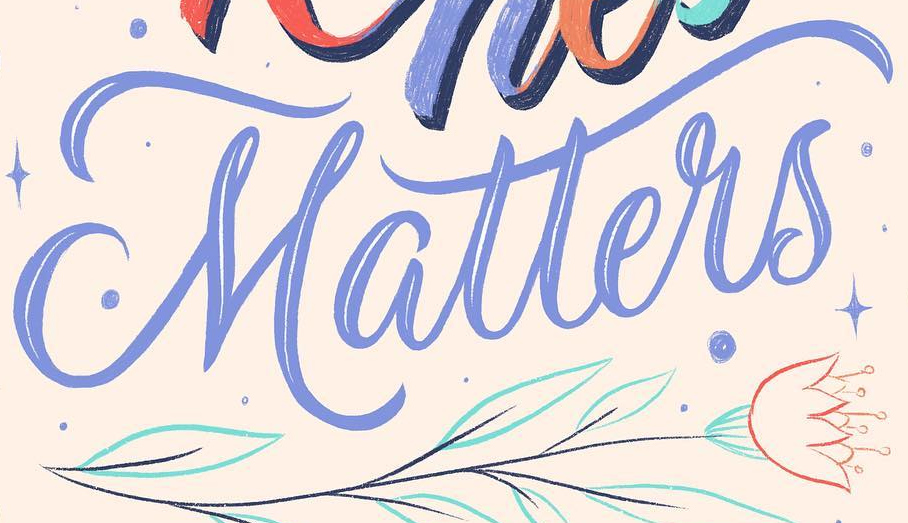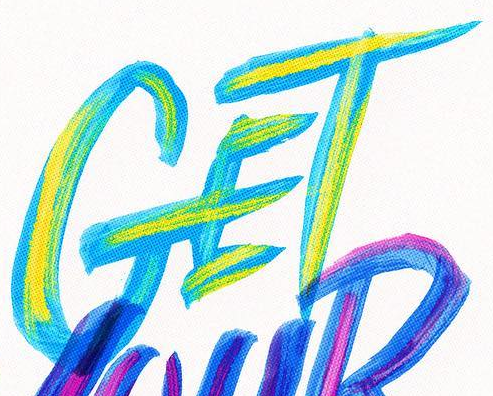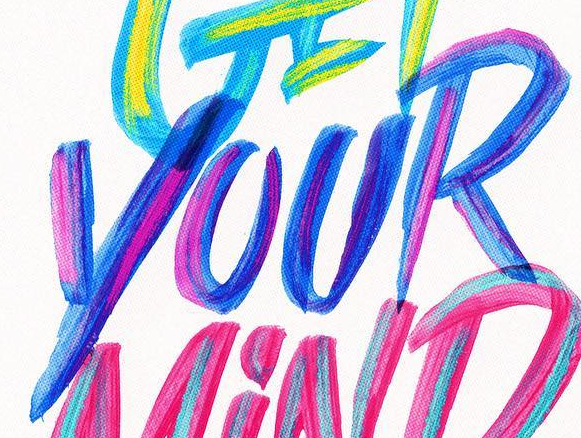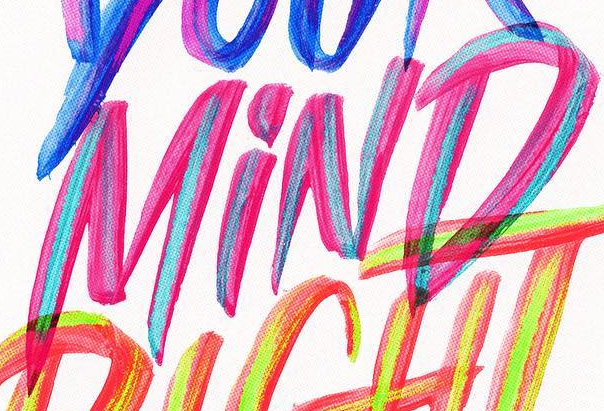Identify the words shown in these images in order, separated by a semicolon. Matters; GET; YOUR; MiND 